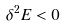<formula> <loc_0><loc_0><loc_500><loc_500>\delta ^ { 2 } E < 0</formula> 